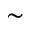<formula> <loc_0><loc_0><loc_500><loc_500>\sim</formula> 